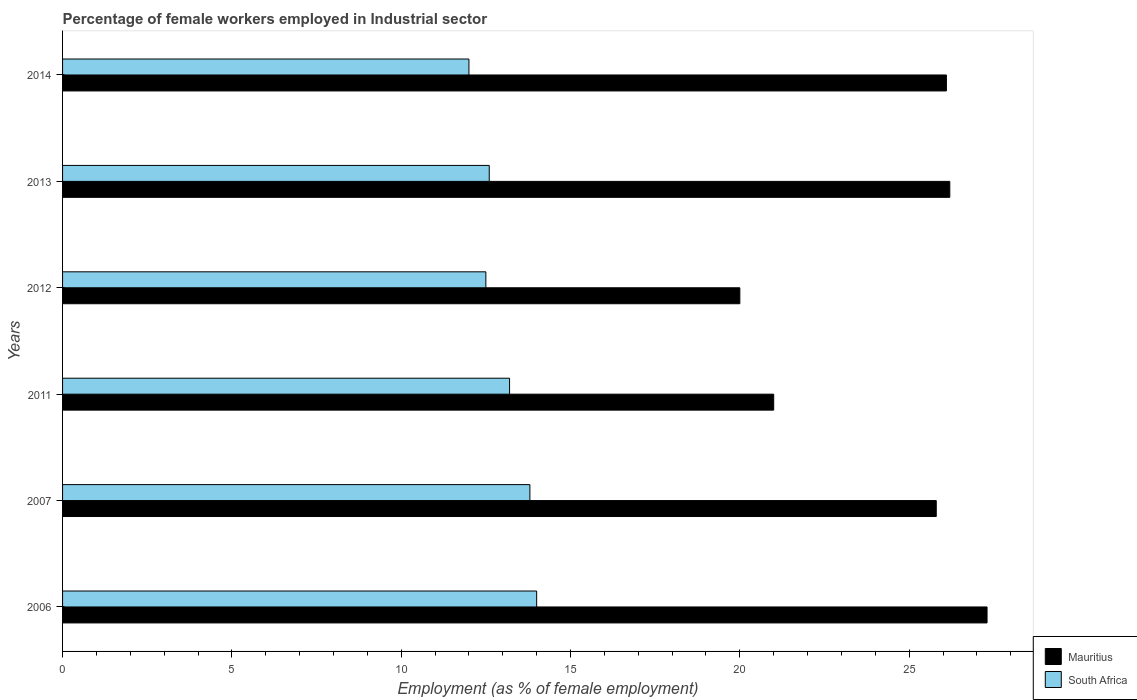How many groups of bars are there?
Offer a terse response. 6. Are the number of bars per tick equal to the number of legend labels?
Keep it short and to the point. Yes. How many bars are there on the 6th tick from the top?
Offer a very short reply. 2. How many bars are there on the 4th tick from the bottom?
Your response must be concise. 2. What is the label of the 6th group of bars from the top?
Your answer should be compact. 2006. In how many cases, is the number of bars for a given year not equal to the number of legend labels?
Provide a succinct answer. 0. Across all years, what is the maximum percentage of females employed in Industrial sector in Mauritius?
Keep it short and to the point. 27.3. What is the total percentage of females employed in Industrial sector in South Africa in the graph?
Provide a succinct answer. 78.1. What is the difference between the percentage of females employed in Industrial sector in South Africa in 2013 and the percentage of females employed in Industrial sector in Mauritius in 2012?
Provide a succinct answer. -7.4. What is the average percentage of females employed in Industrial sector in South Africa per year?
Make the answer very short. 13.02. In the year 2011, what is the difference between the percentage of females employed in Industrial sector in Mauritius and percentage of females employed in Industrial sector in South Africa?
Offer a very short reply. 7.8. In how many years, is the percentage of females employed in Industrial sector in South Africa greater than 26 %?
Keep it short and to the point. 0. What is the ratio of the percentage of females employed in Industrial sector in South Africa in 2013 to that in 2014?
Ensure brevity in your answer.  1.05. Is the percentage of females employed in Industrial sector in South Africa in 2006 less than that in 2014?
Keep it short and to the point. No. What is the difference between the highest and the second highest percentage of females employed in Industrial sector in South Africa?
Keep it short and to the point. 0.2. What is the difference between the highest and the lowest percentage of females employed in Industrial sector in Mauritius?
Your response must be concise. 7.3. In how many years, is the percentage of females employed in Industrial sector in South Africa greater than the average percentage of females employed in Industrial sector in South Africa taken over all years?
Provide a short and direct response. 3. Is the sum of the percentage of females employed in Industrial sector in South Africa in 2006 and 2014 greater than the maximum percentage of females employed in Industrial sector in Mauritius across all years?
Your response must be concise. No. What does the 1st bar from the top in 2014 represents?
Ensure brevity in your answer.  South Africa. What does the 2nd bar from the bottom in 2014 represents?
Offer a very short reply. South Africa. How many bars are there?
Give a very brief answer. 12. How many years are there in the graph?
Your response must be concise. 6. Are the values on the major ticks of X-axis written in scientific E-notation?
Offer a very short reply. No. Where does the legend appear in the graph?
Your answer should be very brief. Bottom right. How many legend labels are there?
Make the answer very short. 2. How are the legend labels stacked?
Offer a terse response. Vertical. What is the title of the graph?
Your answer should be compact. Percentage of female workers employed in Industrial sector. What is the label or title of the X-axis?
Offer a terse response. Employment (as % of female employment). What is the Employment (as % of female employment) of Mauritius in 2006?
Provide a short and direct response. 27.3. What is the Employment (as % of female employment) in Mauritius in 2007?
Give a very brief answer. 25.8. What is the Employment (as % of female employment) of South Africa in 2007?
Your answer should be compact. 13.8. What is the Employment (as % of female employment) in Mauritius in 2011?
Your answer should be compact. 21. What is the Employment (as % of female employment) in South Africa in 2011?
Provide a short and direct response. 13.2. What is the Employment (as % of female employment) in South Africa in 2012?
Ensure brevity in your answer.  12.5. What is the Employment (as % of female employment) of Mauritius in 2013?
Make the answer very short. 26.2. What is the Employment (as % of female employment) in South Africa in 2013?
Your answer should be very brief. 12.6. What is the Employment (as % of female employment) in Mauritius in 2014?
Give a very brief answer. 26.1. Across all years, what is the maximum Employment (as % of female employment) of Mauritius?
Ensure brevity in your answer.  27.3. Across all years, what is the maximum Employment (as % of female employment) of South Africa?
Your answer should be compact. 14. Across all years, what is the minimum Employment (as % of female employment) in South Africa?
Your answer should be very brief. 12. What is the total Employment (as % of female employment) in Mauritius in the graph?
Provide a succinct answer. 146.4. What is the total Employment (as % of female employment) of South Africa in the graph?
Provide a short and direct response. 78.1. What is the difference between the Employment (as % of female employment) in Mauritius in 2006 and that in 2007?
Offer a terse response. 1.5. What is the difference between the Employment (as % of female employment) of Mauritius in 2006 and that in 2011?
Give a very brief answer. 6.3. What is the difference between the Employment (as % of female employment) in South Africa in 2006 and that in 2011?
Your response must be concise. 0.8. What is the difference between the Employment (as % of female employment) in South Africa in 2006 and that in 2012?
Offer a very short reply. 1.5. What is the difference between the Employment (as % of female employment) in South Africa in 2007 and that in 2012?
Ensure brevity in your answer.  1.3. What is the difference between the Employment (as % of female employment) of Mauritius in 2007 and that in 2013?
Provide a short and direct response. -0.4. What is the difference between the Employment (as % of female employment) in South Africa in 2007 and that in 2013?
Your response must be concise. 1.2. What is the difference between the Employment (as % of female employment) of Mauritius in 2007 and that in 2014?
Your answer should be compact. -0.3. What is the difference between the Employment (as % of female employment) in Mauritius in 2011 and that in 2012?
Provide a succinct answer. 1. What is the difference between the Employment (as % of female employment) in South Africa in 2011 and that in 2012?
Keep it short and to the point. 0.7. What is the difference between the Employment (as % of female employment) in Mauritius in 2011 and that in 2013?
Your response must be concise. -5.2. What is the difference between the Employment (as % of female employment) in South Africa in 2011 and that in 2013?
Your answer should be very brief. 0.6. What is the difference between the Employment (as % of female employment) in Mauritius in 2011 and that in 2014?
Your answer should be compact. -5.1. What is the difference between the Employment (as % of female employment) of Mauritius in 2012 and that in 2013?
Offer a terse response. -6.2. What is the difference between the Employment (as % of female employment) of South Africa in 2012 and that in 2013?
Offer a very short reply. -0.1. What is the difference between the Employment (as % of female employment) in Mauritius in 2012 and that in 2014?
Your answer should be compact. -6.1. What is the difference between the Employment (as % of female employment) of South Africa in 2012 and that in 2014?
Keep it short and to the point. 0.5. What is the difference between the Employment (as % of female employment) in Mauritius in 2006 and the Employment (as % of female employment) in South Africa in 2011?
Provide a succinct answer. 14.1. What is the difference between the Employment (as % of female employment) in Mauritius in 2006 and the Employment (as % of female employment) in South Africa in 2012?
Make the answer very short. 14.8. What is the difference between the Employment (as % of female employment) of Mauritius in 2006 and the Employment (as % of female employment) of South Africa in 2014?
Give a very brief answer. 15.3. What is the difference between the Employment (as % of female employment) of Mauritius in 2007 and the Employment (as % of female employment) of South Africa in 2012?
Your answer should be very brief. 13.3. What is the difference between the Employment (as % of female employment) in Mauritius in 2007 and the Employment (as % of female employment) in South Africa in 2013?
Provide a succinct answer. 13.2. What is the difference between the Employment (as % of female employment) of Mauritius in 2007 and the Employment (as % of female employment) of South Africa in 2014?
Provide a succinct answer. 13.8. What is the difference between the Employment (as % of female employment) in Mauritius in 2011 and the Employment (as % of female employment) in South Africa in 2012?
Make the answer very short. 8.5. What is the difference between the Employment (as % of female employment) of Mauritius in 2011 and the Employment (as % of female employment) of South Africa in 2013?
Your response must be concise. 8.4. What is the difference between the Employment (as % of female employment) in Mauritius in 2012 and the Employment (as % of female employment) in South Africa in 2013?
Provide a short and direct response. 7.4. What is the difference between the Employment (as % of female employment) in Mauritius in 2012 and the Employment (as % of female employment) in South Africa in 2014?
Make the answer very short. 8. What is the average Employment (as % of female employment) of Mauritius per year?
Ensure brevity in your answer.  24.4. What is the average Employment (as % of female employment) in South Africa per year?
Keep it short and to the point. 13.02. In the year 2011, what is the difference between the Employment (as % of female employment) of Mauritius and Employment (as % of female employment) of South Africa?
Offer a terse response. 7.8. In the year 2012, what is the difference between the Employment (as % of female employment) of Mauritius and Employment (as % of female employment) of South Africa?
Provide a short and direct response. 7.5. In the year 2013, what is the difference between the Employment (as % of female employment) of Mauritius and Employment (as % of female employment) of South Africa?
Offer a terse response. 13.6. In the year 2014, what is the difference between the Employment (as % of female employment) of Mauritius and Employment (as % of female employment) of South Africa?
Your answer should be very brief. 14.1. What is the ratio of the Employment (as % of female employment) in Mauritius in 2006 to that in 2007?
Provide a succinct answer. 1.06. What is the ratio of the Employment (as % of female employment) in South Africa in 2006 to that in 2007?
Your answer should be compact. 1.01. What is the ratio of the Employment (as % of female employment) of South Africa in 2006 to that in 2011?
Your answer should be very brief. 1.06. What is the ratio of the Employment (as % of female employment) of Mauritius in 2006 to that in 2012?
Ensure brevity in your answer.  1.36. What is the ratio of the Employment (as % of female employment) in South Africa in 2006 to that in 2012?
Offer a terse response. 1.12. What is the ratio of the Employment (as % of female employment) in Mauritius in 2006 to that in 2013?
Provide a succinct answer. 1.04. What is the ratio of the Employment (as % of female employment) of South Africa in 2006 to that in 2013?
Provide a short and direct response. 1.11. What is the ratio of the Employment (as % of female employment) in Mauritius in 2006 to that in 2014?
Offer a terse response. 1.05. What is the ratio of the Employment (as % of female employment) of South Africa in 2006 to that in 2014?
Your answer should be very brief. 1.17. What is the ratio of the Employment (as % of female employment) of Mauritius in 2007 to that in 2011?
Your answer should be very brief. 1.23. What is the ratio of the Employment (as % of female employment) of South Africa in 2007 to that in 2011?
Your answer should be compact. 1.05. What is the ratio of the Employment (as % of female employment) in Mauritius in 2007 to that in 2012?
Provide a succinct answer. 1.29. What is the ratio of the Employment (as % of female employment) of South Africa in 2007 to that in 2012?
Offer a very short reply. 1.1. What is the ratio of the Employment (as % of female employment) in Mauritius in 2007 to that in 2013?
Offer a very short reply. 0.98. What is the ratio of the Employment (as % of female employment) of South Africa in 2007 to that in 2013?
Offer a very short reply. 1.1. What is the ratio of the Employment (as % of female employment) in Mauritius in 2007 to that in 2014?
Keep it short and to the point. 0.99. What is the ratio of the Employment (as % of female employment) in South Africa in 2007 to that in 2014?
Your answer should be compact. 1.15. What is the ratio of the Employment (as % of female employment) of Mauritius in 2011 to that in 2012?
Offer a terse response. 1.05. What is the ratio of the Employment (as % of female employment) in South Africa in 2011 to that in 2012?
Your response must be concise. 1.06. What is the ratio of the Employment (as % of female employment) of Mauritius in 2011 to that in 2013?
Offer a terse response. 0.8. What is the ratio of the Employment (as % of female employment) in South Africa in 2011 to that in 2013?
Keep it short and to the point. 1.05. What is the ratio of the Employment (as % of female employment) of Mauritius in 2011 to that in 2014?
Offer a very short reply. 0.8. What is the ratio of the Employment (as % of female employment) of Mauritius in 2012 to that in 2013?
Provide a succinct answer. 0.76. What is the ratio of the Employment (as % of female employment) of Mauritius in 2012 to that in 2014?
Give a very brief answer. 0.77. What is the ratio of the Employment (as % of female employment) in South Africa in 2012 to that in 2014?
Your answer should be very brief. 1.04. What is the ratio of the Employment (as % of female employment) in Mauritius in 2013 to that in 2014?
Give a very brief answer. 1. What is the difference between the highest and the second highest Employment (as % of female employment) of South Africa?
Your response must be concise. 0.2. What is the difference between the highest and the lowest Employment (as % of female employment) of Mauritius?
Keep it short and to the point. 7.3. 